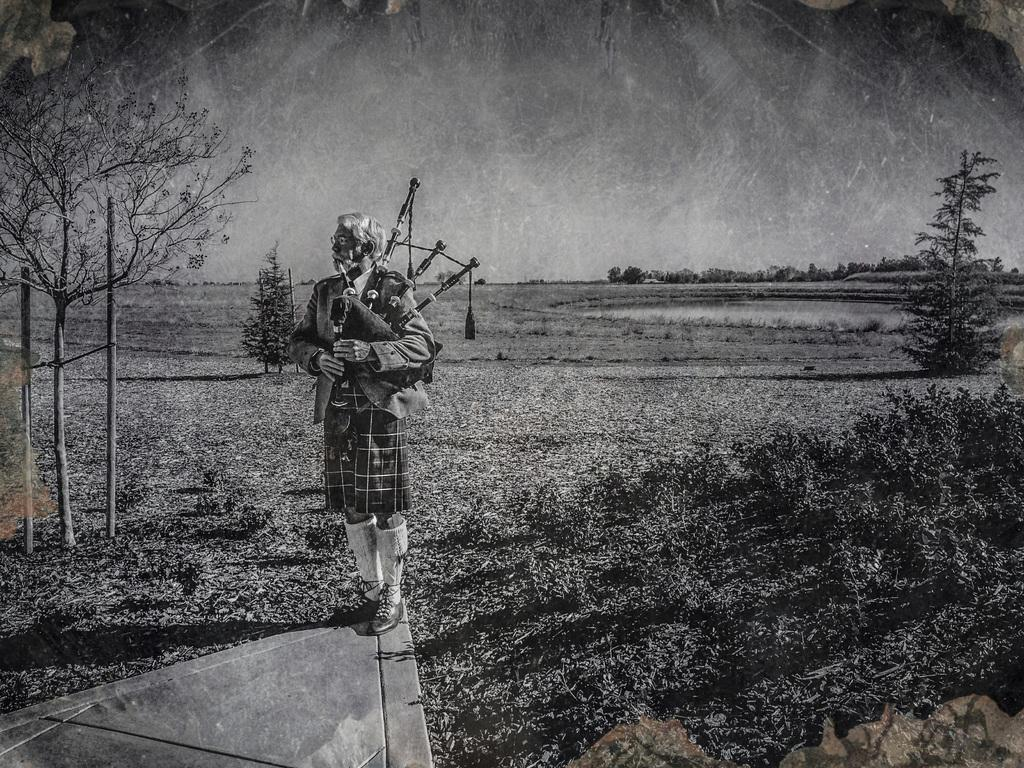What is the man in the image doing? The man is playing pipes in the image. What is the color scheme of the image? The image is in black and white. What can be seen in the background of the image? There is greenery and the sky visible in the background of the image. What type of advertisement is displayed on the bike in the image? There is no bike present in the image, so there cannot be an advertisement on it. What kind of beast is interacting with the man in the image? There is no beast present in the image; the man is playing pipes alone. 